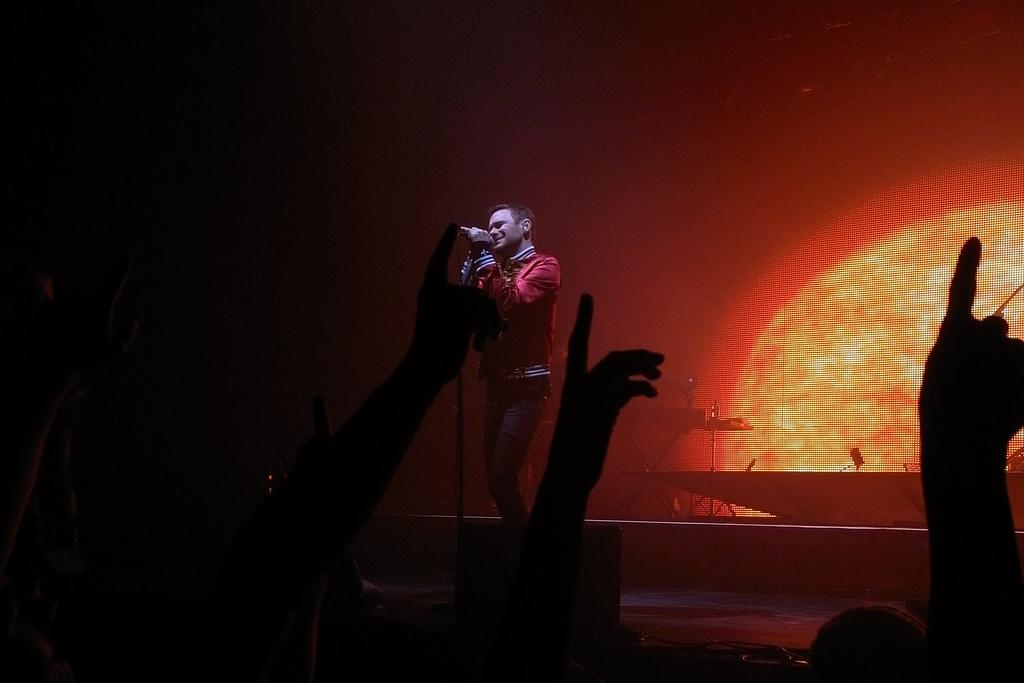What is the man in the image doing? The man is standing in the image and holding a microphone in his hand. What object is the man holding in the image? The man is holding a microphone in his hand. What can be seen in the background of the image? There is a screen visible in the background of the image. What type of tooth is visible in the image? There is no tooth present in the image. What role does the crow play in the image? There is no crow present in the image. 